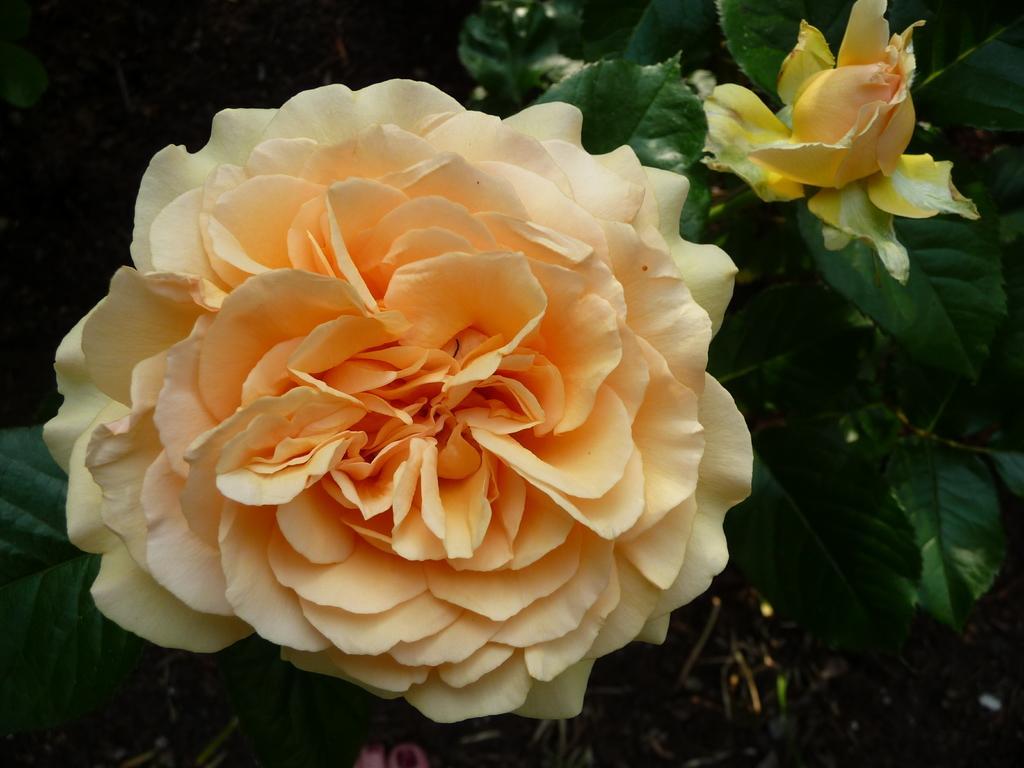In one or two sentences, can you explain what this image depicts? In this picture we can see two flowers and leaves, there is a dark background. 